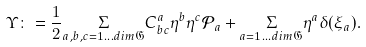<formula> <loc_0><loc_0><loc_500><loc_500>\Upsilon \colon = \frac { 1 } { 2 } \underset { a , b , c = 1 \dots d i m \mathfrak { G } } { \Sigma } C ^ { a } _ { b c } \eta ^ { b } \eta ^ { c } { \mathcal { P } } _ { a } + \underset { a = 1 \dots d i m \mathfrak { G } } { \Sigma } \eta ^ { a } \delta ( \xi _ { a } ) .</formula> 